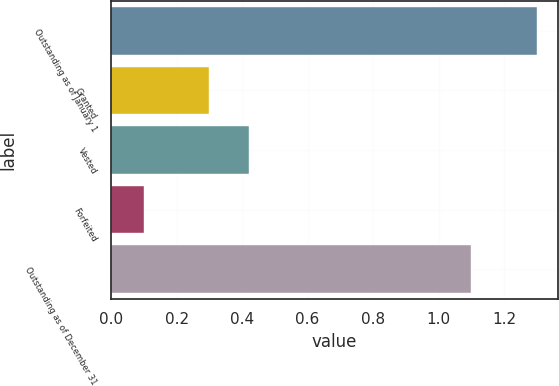Convert chart to OTSL. <chart><loc_0><loc_0><loc_500><loc_500><bar_chart><fcel>Outstanding as of January 1<fcel>Granted<fcel>Vested<fcel>Forfeited<fcel>Outstanding as of December 31<nl><fcel>1.3<fcel>0.3<fcel>0.42<fcel>0.1<fcel>1.1<nl></chart> 